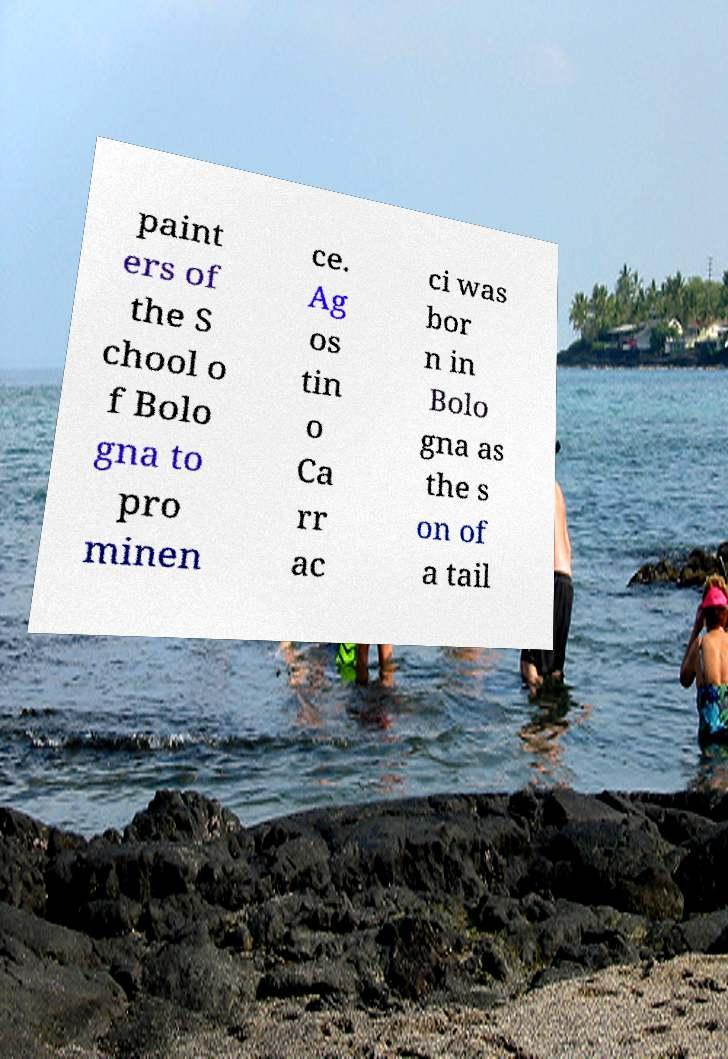I need the written content from this picture converted into text. Can you do that? paint ers of the S chool o f Bolo gna to pro minen ce. Ag os tin o Ca rr ac ci was bor n in Bolo gna as the s on of a tail 